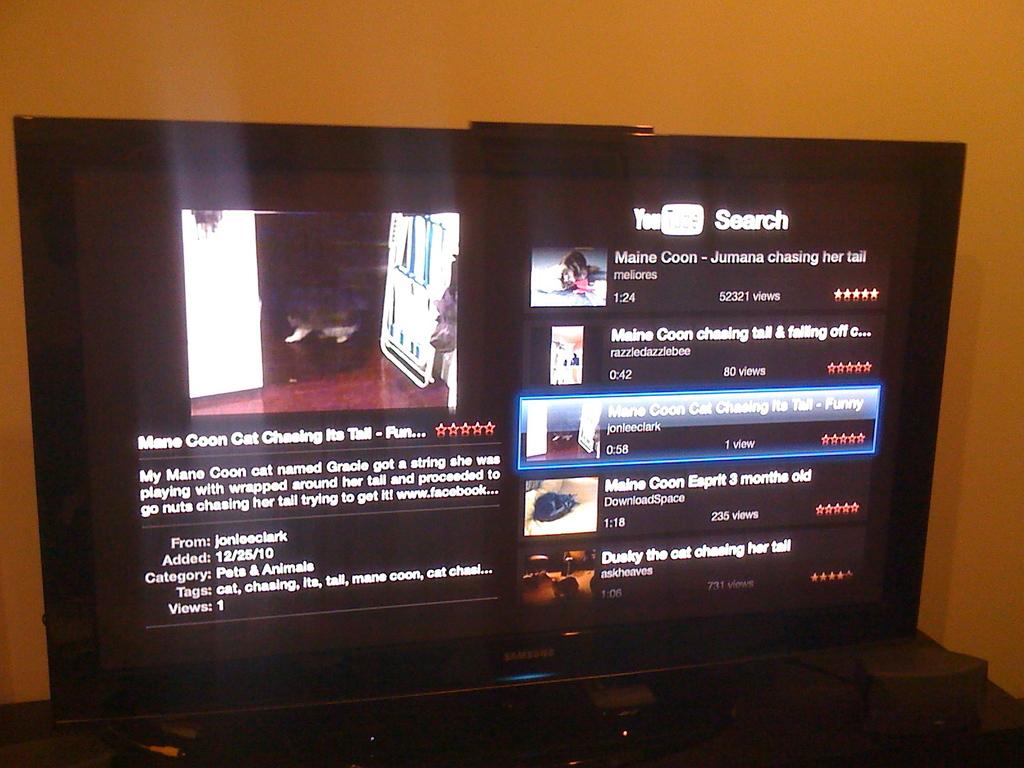What is the title of the clip being watched on the screen?
Your response must be concise. Mane coon cat chasing its tail. Is this a youtube search result?
Ensure brevity in your answer.  Yes. 